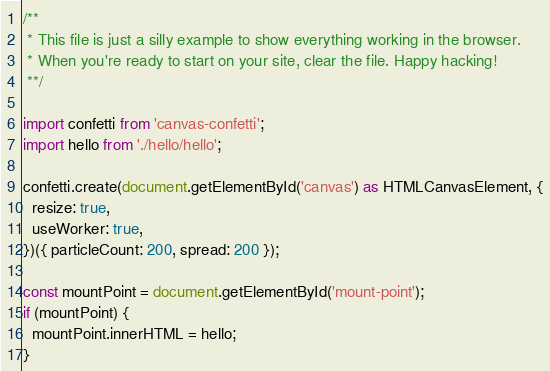<code> <loc_0><loc_0><loc_500><loc_500><_TypeScript_>/**
 * This file is just a silly example to show everything working in the browser.
 * When you're ready to start on your site, clear the file. Happy hacking!
 **/

import confetti from 'canvas-confetti';
import hello from './hello/hello';

confetti.create(document.getElementById('canvas') as HTMLCanvasElement, {
  resize: true,
  useWorker: true,
})({ particleCount: 200, spread: 200 });

const mountPoint = document.getElementById('mount-point');
if (mountPoint) {
  mountPoint.innerHTML = hello;
}
</code> 